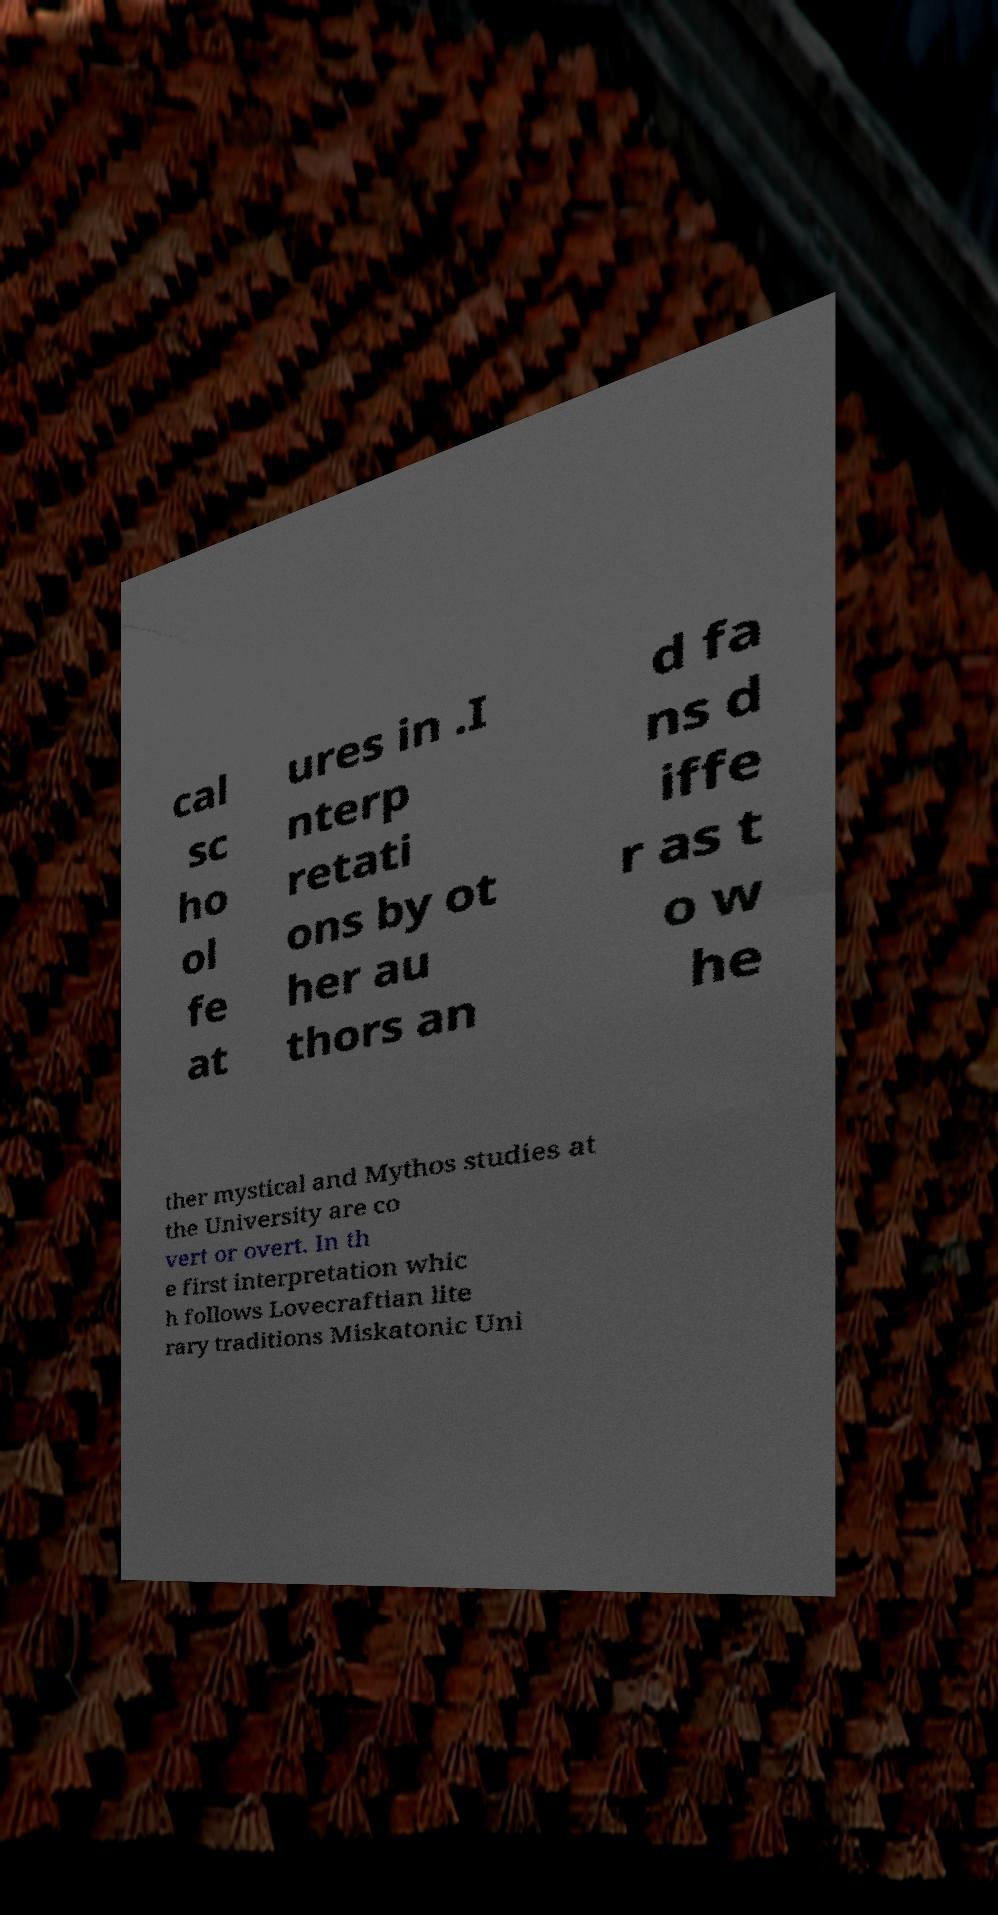What messages or text are displayed in this image? I need them in a readable, typed format. cal sc ho ol fe at ures in .I nterp retati ons by ot her au thors an d fa ns d iffe r as t o w he ther mystical and Mythos studies at the University are co vert or overt. In th e first interpretation whic h follows Lovecraftian lite rary traditions Miskatonic Uni 